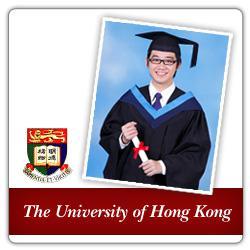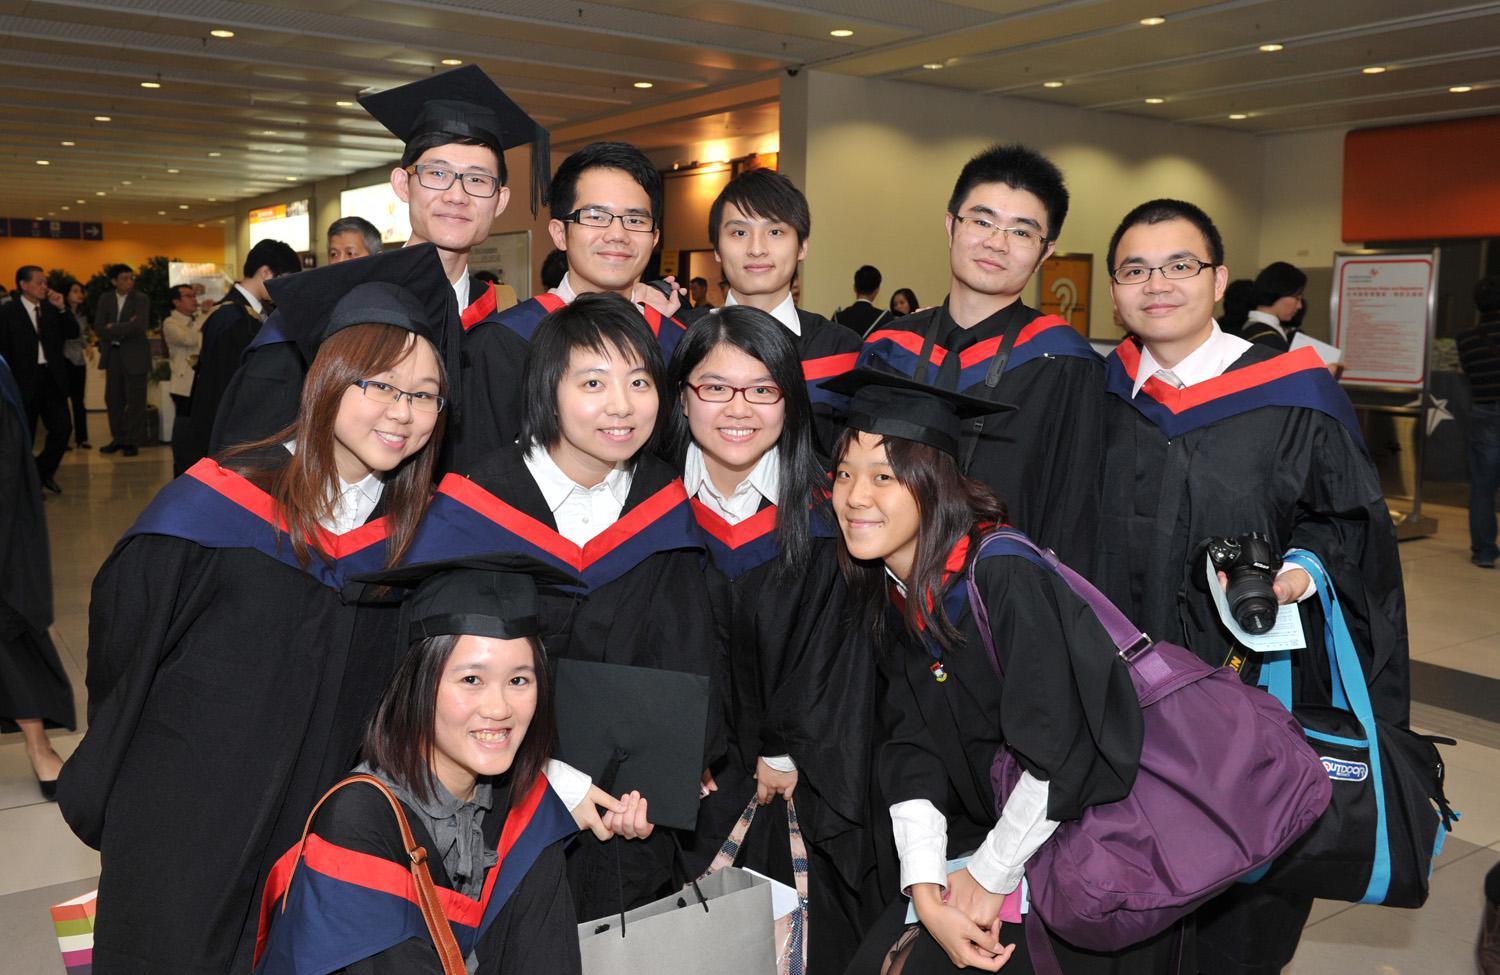The first image is the image on the left, the second image is the image on the right. Given the left and right images, does the statement "The same number of graduates are shown in the left and right images." hold true? Answer yes or no. No. 